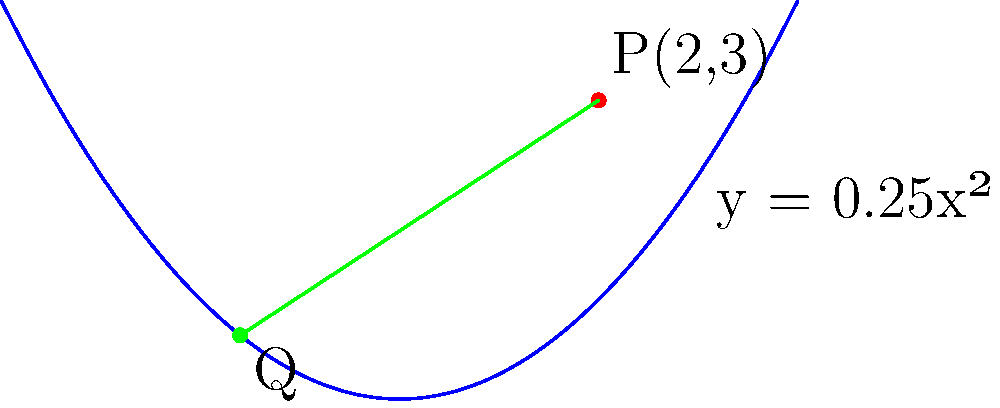Consider the parabola given by the equation $y = 0.25x^2$ and a point $P(2,3)$ in the 2D plane. Find the coordinates of the point $Q$ on the parabola that is closest to point $P$. Round your answer to two decimal places. To find the point $Q$ on the parabola closest to $P$, we follow these steps:

1) The general point on the parabola is $(x, 0.25x^2)$.

2) The square of the distance between $P(2,3)$ and a general point $(x, 0.25x^2)$ on the parabola is:

   $d^2 = (x-2)^2 + (0.25x^2-3)^2$

3) To minimize this distance, we differentiate $d^2$ with respect to $x$ and set it to zero:

   $\frac{d(d^2)}{dx} = 2(x-2) + 2(0.25x^2-3)(0.5x) = 0$

4) Simplifying:

   $(x-2) + (0.25x^2-3)(0.5x) = 0$
   $x - 2 + 0.125x^3 - 1.5x = 0$
   $0.125x^3 - 0.5x - 2 = 0$

5) This cubic equation can be solved numerically. Using a calculator or computer algebra system, we find that $x \approx 1.37$.

6) Substituting this $x$ value into the equation of the parabola:

   $y = 0.25(1.37)^2 \approx 0.47$

Therefore, the coordinates of point $Q$ are approximately $(1.37, 0.47)$.
Answer: $Q(1.37, 0.47)$ 